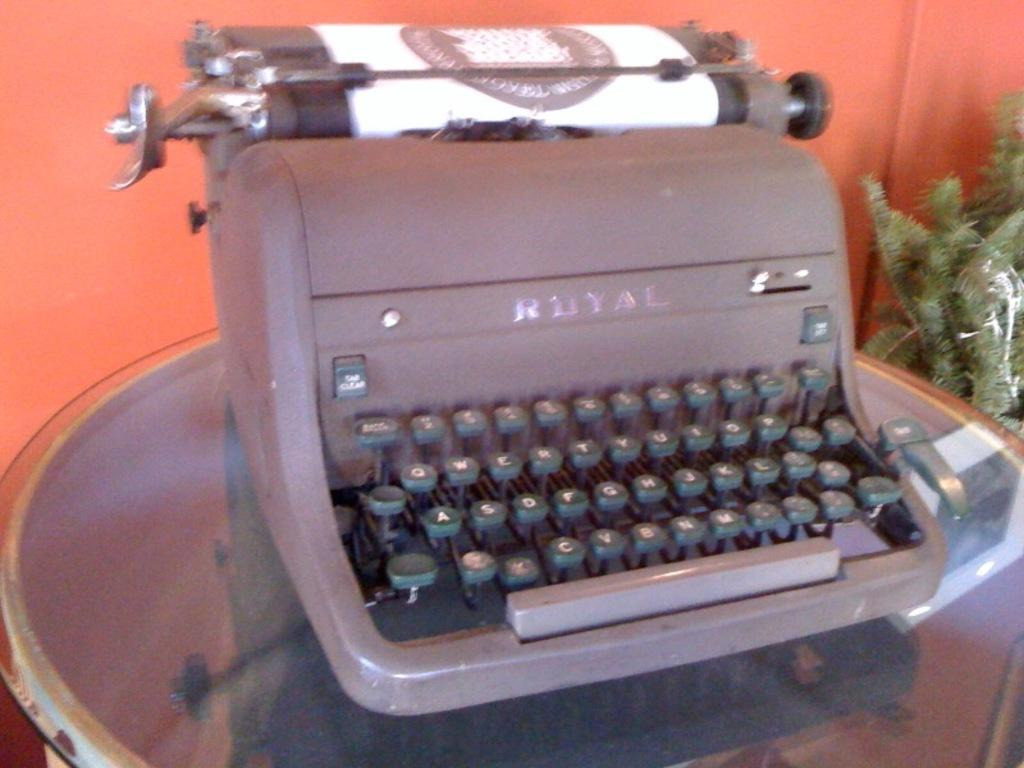Provide a one-sentence caption for the provided image. An ancient Royal typewriter sits on a display table. 